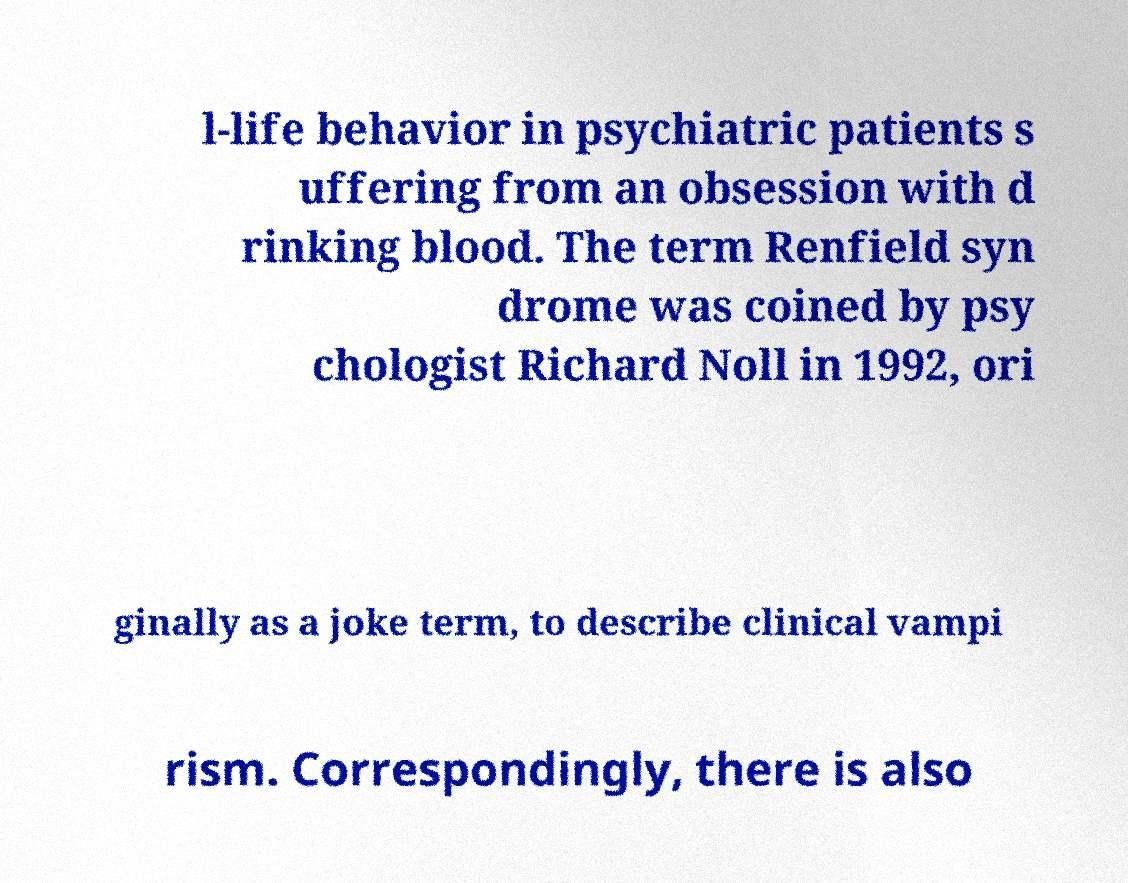There's text embedded in this image that I need extracted. Can you transcribe it verbatim? l-life behavior in psychiatric patients s uffering from an obsession with d rinking blood. The term Renfield syn drome was coined by psy chologist Richard Noll in 1992, ori ginally as a joke term, to describe clinical vampi rism. Correspondingly, there is also 